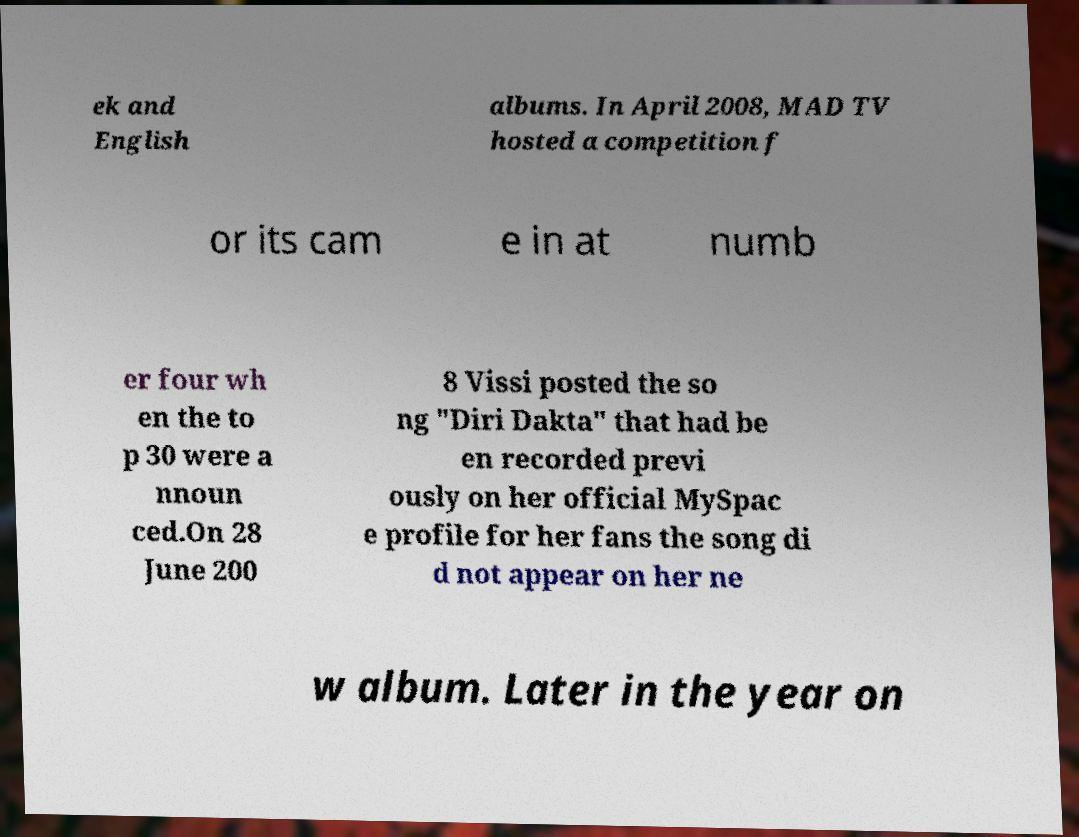Please read and relay the text visible in this image. What does it say? ek and English albums. In April 2008, MAD TV hosted a competition f or its cam e in at numb er four wh en the to p 30 were a nnoun ced.On 28 June 200 8 Vissi posted the so ng "Diri Dakta" that had be en recorded previ ously on her official MySpac e profile for her fans the song di d not appear on her ne w album. Later in the year on 